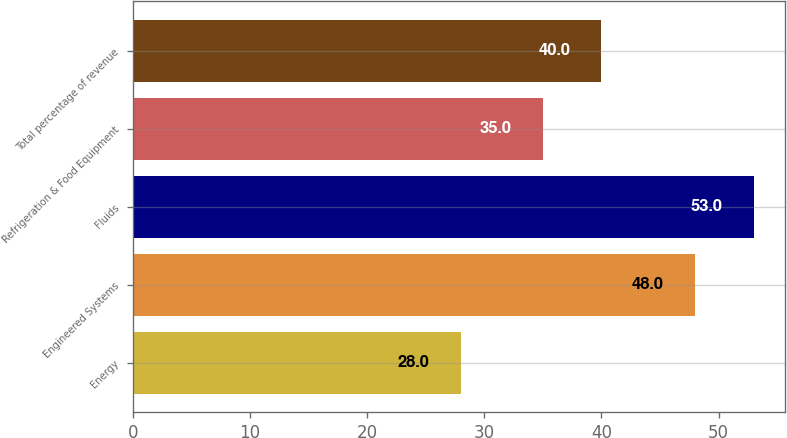Convert chart. <chart><loc_0><loc_0><loc_500><loc_500><bar_chart><fcel>Energy<fcel>Engineered Systems<fcel>Fluids<fcel>Refrigeration & Food Equipment<fcel>Total percentage of revenue<nl><fcel>28<fcel>48<fcel>53<fcel>35<fcel>40<nl></chart> 